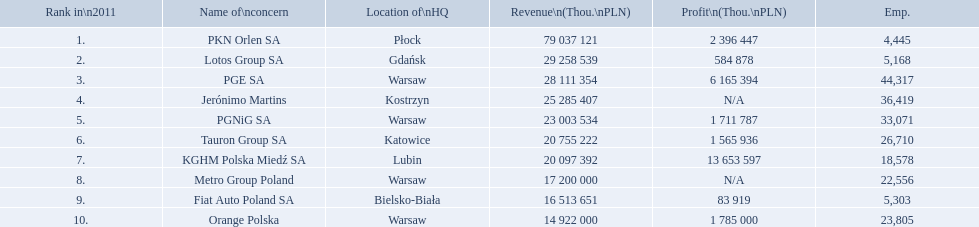Which concern's headquarters are located in warsaw? PGE SA, PGNiG SA, Metro Group Poland. Which of these listed a profit? PGE SA, PGNiG SA. Of these how many employees are in the concern with the lowest profit? 33,071. What are the names of all the concerns? PKN Orlen SA, Lotos Group SA, PGE SA, Jerónimo Martins, PGNiG SA, Tauron Group SA, KGHM Polska Miedź SA, Metro Group Poland, Fiat Auto Poland SA, Orange Polska. How many employees does pgnig sa have? 33,071. 